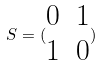<formula> <loc_0><loc_0><loc_500><loc_500>S = ( \begin{matrix} 0 & 1 \\ 1 & 0 \end{matrix} )</formula> 